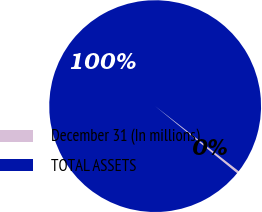Convert chart. <chart><loc_0><loc_0><loc_500><loc_500><pie_chart><fcel>December 31 (In millions)<fcel>TOTAL ASSETS<nl><fcel>0.37%<fcel>99.63%<nl></chart> 